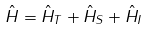<formula> <loc_0><loc_0><loc_500><loc_500>\hat { H } = \hat { H } _ { T } + \hat { H } _ { S } + \hat { H } _ { I }</formula> 